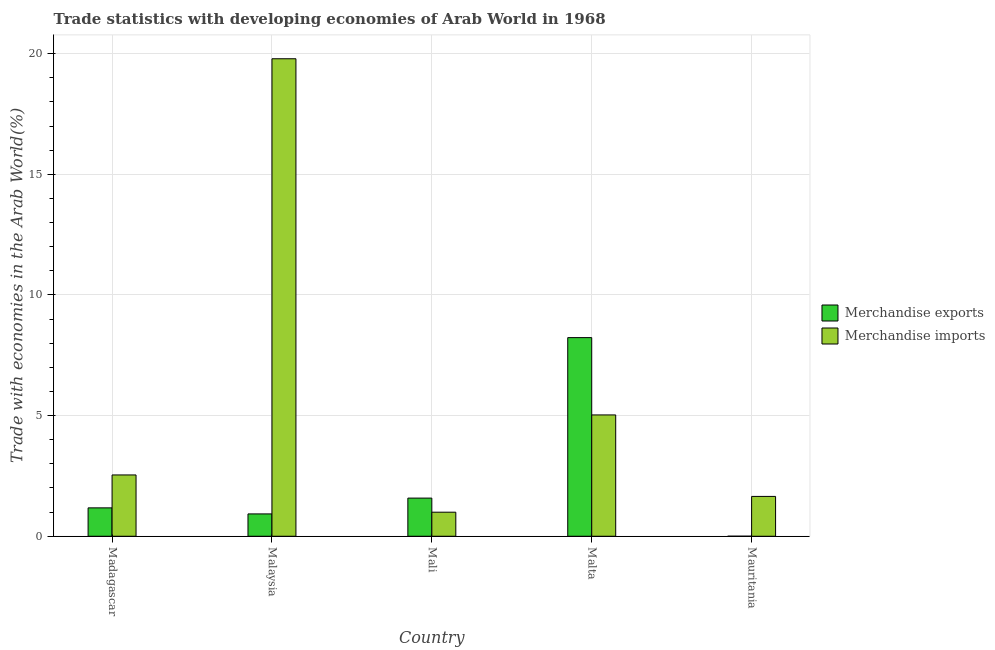How many groups of bars are there?
Provide a short and direct response. 5. Are the number of bars per tick equal to the number of legend labels?
Keep it short and to the point. Yes. How many bars are there on the 1st tick from the left?
Your response must be concise. 2. What is the label of the 4th group of bars from the left?
Your answer should be very brief. Malta. In how many cases, is the number of bars for a given country not equal to the number of legend labels?
Your response must be concise. 0. What is the merchandise imports in Madagascar?
Offer a very short reply. 2.54. Across all countries, what is the maximum merchandise imports?
Your response must be concise. 19.79. Across all countries, what is the minimum merchandise imports?
Offer a very short reply. 1. In which country was the merchandise imports maximum?
Make the answer very short. Malaysia. In which country was the merchandise imports minimum?
Give a very brief answer. Mali. What is the total merchandise imports in the graph?
Your answer should be compact. 30.01. What is the difference between the merchandise imports in Malaysia and that in Mauritania?
Offer a terse response. 18.14. What is the difference between the merchandise imports in Madagascar and the merchandise exports in Mali?
Your response must be concise. 0.96. What is the average merchandise imports per country?
Your answer should be very brief. 6. What is the difference between the merchandise exports and merchandise imports in Mauritania?
Provide a short and direct response. -1.65. In how many countries, is the merchandise exports greater than 7 %?
Provide a short and direct response. 1. What is the ratio of the merchandise imports in Malaysia to that in Malta?
Keep it short and to the point. 3.94. Is the merchandise imports in Malaysia less than that in Mauritania?
Give a very brief answer. No. Is the difference between the merchandise exports in Madagascar and Malta greater than the difference between the merchandise imports in Madagascar and Malta?
Offer a very short reply. No. What is the difference between the highest and the second highest merchandise imports?
Give a very brief answer. 14.76. What is the difference between the highest and the lowest merchandise exports?
Ensure brevity in your answer.  8.23. What does the 2nd bar from the left in Malaysia represents?
Your answer should be very brief. Merchandise imports. What does the 2nd bar from the right in Madagascar represents?
Offer a very short reply. Merchandise exports. What is the difference between two consecutive major ticks on the Y-axis?
Offer a terse response. 5. Where does the legend appear in the graph?
Provide a short and direct response. Center right. What is the title of the graph?
Your answer should be very brief. Trade statistics with developing economies of Arab World in 1968. Does "Education" appear as one of the legend labels in the graph?
Give a very brief answer. No. What is the label or title of the Y-axis?
Make the answer very short. Trade with economies in the Arab World(%). What is the Trade with economies in the Arab World(%) of Merchandise exports in Madagascar?
Offer a terse response. 1.18. What is the Trade with economies in the Arab World(%) in Merchandise imports in Madagascar?
Provide a short and direct response. 2.54. What is the Trade with economies in the Arab World(%) of Merchandise exports in Malaysia?
Give a very brief answer. 0.93. What is the Trade with economies in the Arab World(%) of Merchandise imports in Malaysia?
Offer a terse response. 19.79. What is the Trade with economies in the Arab World(%) in Merchandise exports in Mali?
Your answer should be compact. 1.58. What is the Trade with economies in the Arab World(%) of Merchandise imports in Mali?
Your answer should be very brief. 1. What is the Trade with economies in the Arab World(%) of Merchandise exports in Malta?
Ensure brevity in your answer.  8.23. What is the Trade with economies in the Arab World(%) of Merchandise imports in Malta?
Offer a terse response. 5.03. What is the Trade with economies in the Arab World(%) in Merchandise exports in Mauritania?
Provide a succinct answer. 0. What is the Trade with economies in the Arab World(%) in Merchandise imports in Mauritania?
Your response must be concise. 1.65. Across all countries, what is the maximum Trade with economies in the Arab World(%) in Merchandise exports?
Keep it short and to the point. 8.23. Across all countries, what is the maximum Trade with economies in the Arab World(%) in Merchandise imports?
Offer a terse response. 19.79. Across all countries, what is the minimum Trade with economies in the Arab World(%) in Merchandise exports?
Keep it short and to the point. 0. Across all countries, what is the minimum Trade with economies in the Arab World(%) in Merchandise imports?
Ensure brevity in your answer.  1. What is the total Trade with economies in the Arab World(%) of Merchandise exports in the graph?
Your answer should be compact. 11.92. What is the total Trade with economies in the Arab World(%) of Merchandise imports in the graph?
Provide a short and direct response. 30.01. What is the difference between the Trade with economies in the Arab World(%) in Merchandise exports in Madagascar and that in Malaysia?
Ensure brevity in your answer.  0.25. What is the difference between the Trade with economies in the Arab World(%) in Merchandise imports in Madagascar and that in Malaysia?
Provide a short and direct response. -17.25. What is the difference between the Trade with economies in the Arab World(%) in Merchandise exports in Madagascar and that in Mali?
Your response must be concise. -0.4. What is the difference between the Trade with economies in the Arab World(%) of Merchandise imports in Madagascar and that in Mali?
Your response must be concise. 1.54. What is the difference between the Trade with economies in the Arab World(%) in Merchandise exports in Madagascar and that in Malta?
Provide a short and direct response. -7.06. What is the difference between the Trade with economies in the Arab World(%) in Merchandise imports in Madagascar and that in Malta?
Provide a succinct answer. -2.49. What is the difference between the Trade with economies in the Arab World(%) of Merchandise exports in Madagascar and that in Mauritania?
Your response must be concise. 1.18. What is the difference between the Trade with economies in the Arab World(%) in Merchandise imports in Madagascar and that in Mauritania?
Ensure brevity in your answer.  0.89. What is the difference between the Trade with economies in the Arab World(%) in Merchandise exports in Malaysia and that in Mali?
Your answer should be very brief. -0.66. What is the difference between the Trade with economies in the Arab World(%) in Merchandise imports in Malaysia and that in Mali?
Provide a succinct answer. 18.79. What is the difference between the Trade with economies in the Arab World(%) in Merchandise exports in Malaysia and that in Malta?
Make the answer very short. -7.31. What is the difference between the Trade with economies in the Arab World(%) in Merchandise imports in Malaysia and that in Malta?
Make the answer very short. 14.76. What is the difference between the Trade with economies in the Arab World(%) in Merchandise exports in Malaysia and that in Mauritania?
Make the answer very short. 0.92. What is the difference between the Trade with economies in the Arab World(%) in Merchandise imports in Malaysia and that in Mauritania?
Provide a succinct answer. 18.14. What is the difference between the Trade with economies in the Arab World(%) of Merchandise exports in Mali and that in Malta?
Provide a succinct answer. -6.65. What is the difference between the Trade with economies in the Arab World(%) in Merchandise imports in Mali and that in Malta?
Keep it short and to the point. -4.03. What is the difference between the Trade with economies in the Arab World(%) in Merchandise exports in Mali and that in Mauritania?
Your answer should be compact. 1.58. What is the difference between the Trade with economies in the Arab World(%) in Merchandise imports in Mali and that in Mauritania?
Give a very brief answer. -0.65. What is the difference between the Trade with economies in the Arab World(%) of Merchandise exports in Malta and that in Mauritania?
Your response must be concise. 8.23. What is the difference between the Trade with economies in the Arab World(%) in Merchandise imports in Malta and that in Mauritania?
Offer a very short reply. 3.38. What is the difference between the Trade with economies in the Arab World(%) in Merchandise exports in Madagascar and the Trade with economies in the Arab World(%) in Merchandise imports in Malaysia?
Provide a succinct answer. -18.61. What is the difference between the Trade with economies in the Arab World(%) in Merchandise exports in Madagascar and the Trade with economies in the Arab World(%) in Merchandise imports in Mali?
Give a very brief answer. 0.18. What is the difference between the Trade with economies in the Arab World(%) of Merchandise exports in Madagascar and the Trade with economies in the Arab World(%) of Merchandise imports in Malta?
Make the answer very short. -3.85. What is the difference between the Trade with economies in the Arab World(%) in Merchandise exports in Madagascar and the Trade with economies in the Arab World(%) in Merchandise imports in Mauritania?
Offer a terse response. -0.47. What is the difference between the Trade with economies in the Arab World(%) of Merchandise exports in Malaysia and the Trade with economies in the Arab World(%) of Merchandise imports in Mali?
Keep it short and to the point. -0.07. What is the difference between the Trade with economies in the Arab World(%) of Merchandise exports in Malaysia and the Trade with economies in the Arab World(%) of Merchandise imports in Malta?
Offer a very short reply. -4.1. What is the difference between the Trade with economies in the Arab World(%) in Merchandise exports in Malaysia and the Trade with economies in the Arab World(%) in Merchandise imports in Mauritania?
Provide a succinct answer. -0.73. What is the difference between the Trade with economies in the Arab World(%) of Merchandise exports in Mali and the Trade with economies in the Arab World(%) of Merchandise imports in Malta?
Provide a short and direct response. -3.45. What is the difference between the Trade with economies in the Arab World(%) in Merchandise exports in Mali and the Trade with economies in the Arab World(%) in Merchandise imports in Mauritania?
Your response must be concise. -0.07. What is the difference between the Trade with economies in the Arab World(%) of Merchandise exports in Malta and the Trade with economies in the Arab World(%) of Merchandise imports in Mauritania?
Provide a short and direct response. 6.58. What is the average Trade with economies in the Arab World(%) of Merchandise exports per country?
Keep it short and to the point. 2.38. What is the average Trade with economies in the Arab World(%) of Merchandise imports per country?
Provide a short and direct response. 6. What is the difference between the Trade with economies in the Arab World(%) in Merchandise exports and Trade with economies in the Arab World(%) in Merchandise imports in Madagascar?
Your answer should be very brief. -1.36. What is the difference between the Trade with economies in the Arab World(%) in Merchandise exports and Trade with economies in the Arab World(%) in Merchandise imports in Malaysia?
Your answer should be compact. -18.86. What is the difference between the Trade with economies in the Arab World(%) of Merchandise exports and Trade with economies in the Arab World(%) of Merchandise imports in Mali?
Make the answer very short. 0.58. What is the difference between the Trade with economies in the Arab World(%) of Merchandise exports and Trade with economies in the Arab World(%) of Merchandise imports in Malta?
Offer a terse response. 3.2. What is the difference between the Trade with economies in the Arab World(%) in Merchandise exports and Trade with economies in the Arab World(%) in Merchandise imports in Mauritania?
Offer a terse response. -1.65. What is the ratio of the Trade with economies in the Arab World(%) in Merchandise exports in Madagascar to that in Malaysia?
Give a very brief answer. 1.27. What is the ratio of the Trade with economies in the Arab World(%) of Merchandise imports in Madagascar to that in Malaysia?
Provide a succinct answer. 0.13. What is the ratio of the Trade with economies in the Arab World(%) in Merchandise exports in Madagascar to that in Mali?
Make the answer very short. 0.74. What is the ratio of the Trade with economies in the Arab World(%) in Merchandise imports in Madagascar to that in Mali?
Offer a terse response. 2.55. What is the ratio of the Trade with economies in the Arab World(%) of Merchandise exports in Madagascar to that in Malta?
Make the answer very short. 0.14. What is the ratio of the Trade with economies in the Arab World(%) in Merchandise imports in Madagascar to that in Malta?
Your answer should be very brief. 0.51. What is the ratio of the Trade with economies in the Arab World(%) in Merchandise exports in Madagascar to that in Mauritania?
Make the answer very short. 844.21. What is the ratio of the Trade with economies in the Arab World(%) in Merchandise imports in Madagascar to that in Mauritania?
Offer a very short reply. 1.54. What is the ratio of the Trade with economies in the Arab World(%) in Merchandise exports in Malaysia to that in Mali?
Give a very brief answer. 0.59. What is the ratio of the Trade with economies in the Arab World(%) in Merchandise imports in Malaysia to that in Mali?
Offer a very short reply. 19.86. What is the ratio of the Trade with economies in the Arab World(%) of Merchandise exports in Malaysia to that in Malta?
Provide a succinct answer. 0.11. What is the ratio of the Trade with economies in the Arab World(%) of Merchandise imports in Malaysia to that in Malta?
Offer a very short reply. 3.94. What is the ratio of the Trade with economies in the Arab World(%) of Merchandise exports in Malaysia to that in Mauritania?
Make the answer very short. 664.34. What is the ratio of the Trade with economies in the Arab World(%) of Merchandise imports in Malaysia to that in Mauritania?
Provide a short and direct response. 11.99. What is the ratio of the Trade with economies in the Arab World(%) of Merchandise exports in Mali to that in Malta?
Offer a very short reply. 0.19. What is the ratio of the Trade with economies in the Arab World(%) of Merchandise imports in Mali to that in Malta?
Your answer should be very brief. 0.2. What is the ratio of the Trade with economies in the Arab World(%) in Merchandise exports in Mali to that in Mauritania?
Give a very brief answer. 1134.51. What is the ratio of the Trade with economies in the Arab World(%) of Merchandise imports in Mali to that in Mauritania?
Offer a terse response. 0.6. What is the ratio of the Trade with economies in the Arab World(%) of Merchandise exports in Malta to that in Mauritania?
Make the answer very short. 5906.91. What is the ratio of the Trade with economies in the Arab World(%) of Merchandise imports in Malta to that in Mauritania?
Provide a short and direct response. 3.05. What is the difference between the highest and the second highest Trade with economies in the Arab World(%) in Merchandise exports?
Provide a succinct answer. 6.65. What is the difference between the highest and the second highest Trade with economies in the Arab World(%) in Merchandise imports?
Provide a succinct answer. 14.76. What is the difference between the highest and the lowest Trade with economies in the Arab World(%) of Merchandise exports?
Provide a succinct answer. 8.23. What is the difference between the highest and the lowest Trade with economies in the Arab World(%) of Merchandise imports?
Your response must be concise. 18.79. 